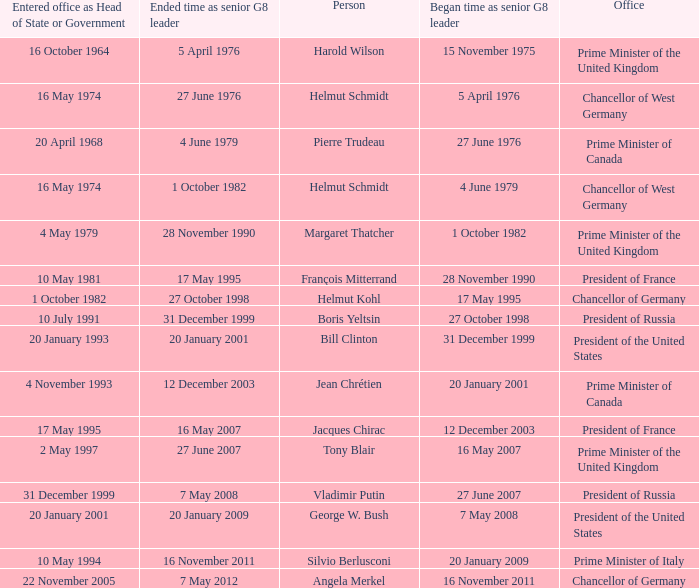When did Jacques Chirac stop being a G8 leader? 16 May 2007. 